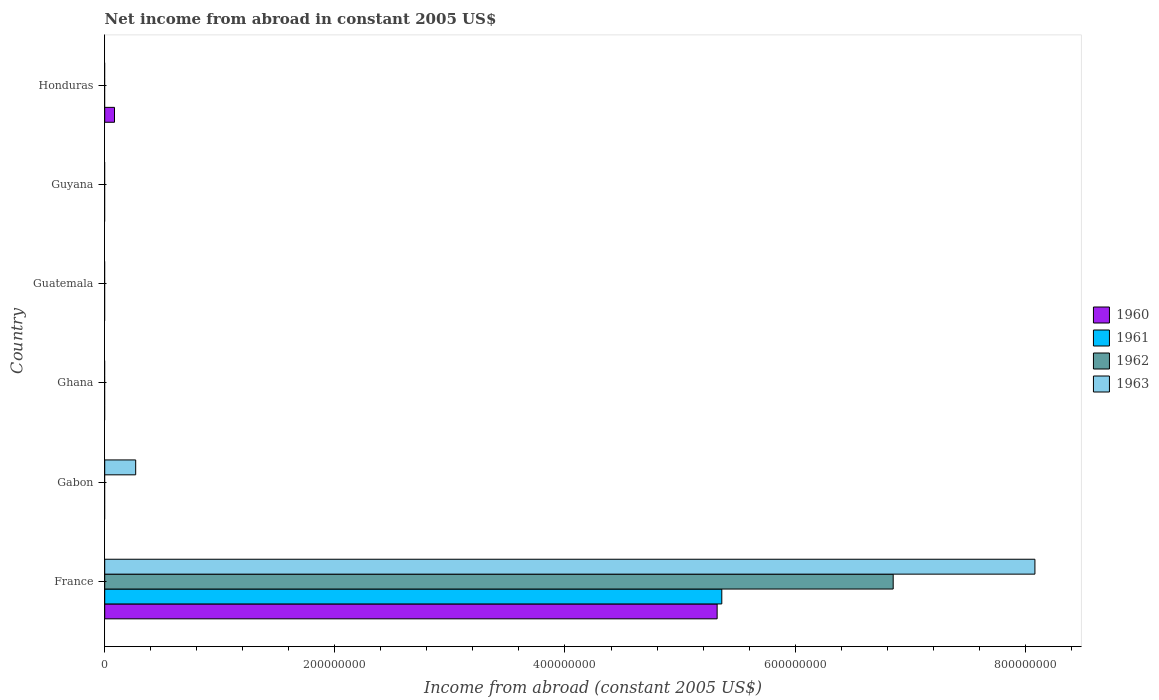How many different coloured bars are there?
Offer a very short reply. 4. Are the number of bars per tick equal to the number of legend labels?
Give a very brief answer. No. How many bars are there on the 2nd tick from the bottom?
Ensure brevity in your answer.  1. What is the label of the 3rd group of bars from the top?
Offer a terse response. Guatemala. In how many cases, is the number of bars for a given country not equal to the number of legend labels?
Your answer should be very brief. 5. Across all countries, what is the maximum net income from abroad in 1962?
Your answer should be very brief. 6.85e+08. In which country was the net income from abroad in 1962 maximum?
Your answer should be compact. France. What is the total net income from abroad in 1960 in the graph?
Your response must be concise. 5.41e+08. What is the difference between the net income from abroad in 1960 in France and that in Honduras?
Provide a succinct answer. 5.24e+08. What is the difference between the net income from abroad in 1961 in Guatemala and the net income from abroad in 1963 in Gabon?
Provide a succinct answer. -2.69e+07. What is the average net income from abroad in 1963 per country?
Provide a short and direct response. 1.39e+08. What is the difference between the highest and the lowest net income from abroad in 1962?
Provide a succinct answer. 6.85e+08. In how many countries, is the net income from abroad in 1962 greater than the average net income from abroad in 1962 taken over all countries?
Ensure brevity in your answer.  1. Is it the case that in every country, the sum of the net income from abroad in 1960 and net income from abroad in 1962 is greater than the net income from abroad in 1963?
Provide a succinct answer. No. How many bars are there?
Keep it short and to the point. 6. What is the difference between two consecutive major ticks on the X-axis?
Provide a succinct answer. 2.00e+08. Does the graph contain grids?
Ensure brevity in your answer.  No. Where does the legend appear in the graph?
Your answer should be compact. Center right. How many legend labels are there?
Keep it short and to the point. 4. What is the title of the graph?
Make the answer very short. Net income from abroad in constant 2005 US$. What is the label or title of the X-axis?
Give a very brief answer. Income from abroad (constant 2005 US$). What is the Income from abroad (constant 2005 US$) of 1960 in France?
Keep it short and to the point. 5.32e+08. What is the Income from abroad (constant 2005 US$) in 1961 in France?
Give a very brief answer. 5.36e+08. What is the Income from abroad (constant 2005 US$) of 1962 in France?
Provide a succinct answer. 6.85e+08. What is the Income from abroad (constant 2005 US$) in 1963 in France?
Offer a terse response. 8.08e+08. What is the Income from abroad (constant 2005 US$) in 1960 in Gabon?
Offer a terse response. 0. What is the Income from abroad (constant 2005 US$) in 1963 in Gabon?
Offer a terse response. 2.69e+07. What is the Income from abroad (constant 2005 US$) of 1960 in Ghana?
Provide a short and direct response. 0. What is the Income from abroad (constant 2005 US$) of 1961 in Ghana?
Provide a succinct answer. 0. What is the Income from abroad (constant 2005 US$) in 1963 in Ghana?
Offer a very short reply. 0. What is the Income from abroad (constant 2005 US$) in 1963 in Guatemala?
Offer a terse response. 0. What is the Income from abroad (constant 2005 US$) in 1960 in Guyana?
Provide a succinct answer. 0. What is the Income from abroad (constant 2005 US$) in 1963 in Guyana?
Your response must be concise. 0. What is the Income from abroad (constant 2005 US$) of 1960 in Honduras?
Offer a very short reply. 8.50e+06. What is the Income from abroad (constant 2005 US$) in 1961 in Honduras?
Provide a short and direct response. 0. Across all countries, what is the maximum Income from abroad (constant 2005 US$) in 1960?
Your answer should be very brief. 5.32e+08. Across all countries, what is the maximum Income from abroad (constant 2005 US$) of 1961?
Provide a succinct answer. 5.36e+08. Across all countries, what is the maximum Income from abroad (constant 2005 US$) of 1962?
Offer a very short reply. 6.85e+08. Across all countries, what is the maximum Income from abroad (constant 2005 US$) of 1963?
Ensure brevity in your answer.  8.08e+08. Across all countries, what is the minimum Income from abroad (constant 2005 US$) of 1963?
Provide a succinct answer. 0. What is the total Income from abroad (constant 2005 US$) in 1960 in the graph?
Give a very brief answer. 5.41e+08. What is the total Income from abroad (constant 2005 US$) of 1961 in the graph?
Your answer should be compact. 5.36e+08. What is the total Income from abroad (constant 2005 US$) of 1962 in the graph?
Make the answer very short. 6.85e+08. What is the total Income from abroad (constant 2005 US$) of 1963 in the graph?
Your response must be concise. 8.35e+08. What is the difference between the Income from abroad (constant 2005 US$) in 1963 in France and that in Gabon?
Make the answer very short. 7.81e+08. What is the difference between the Income from abroad (constant 2005 US$) in 1960 in France and that in Honduras?
Make the answer very short. 5.24e+08. What is the difference between the Income from abroad (constant 2005 US$) in 1960 in France and the Income from abroad (constant 2005 US$) in 1963 in Gabon?
Your answer should be very brief. 5.05e+08. What is the difference between the Income from abroad (constant 2005 US$) in 1961 in France and the Income from abroad (constant 2005 US$) in 1963 in Gabon?
Offer a terse response. 5.09e+08. What is the difference between the Income from abroad (constant 2005 US$) of 1962 in France and the Income from abroad (constant 2005 US$) of 1963 in Gabon?
Offer a terse response. 6.58e+08. What is the average Income from abroad (constant 2005 US$) in 1960 per country?
Your answer should be compact. 9.01e+07. What is the average Income from abroad (constant 2005 US$) in 1961 per country?
Your response must be concise. 8.94e+07. What is the average Income from abroad (constant 2005 US$) of 1962 per country?
Provide a succinct answer. 1.14e+08. What is the average Income from abroad (constant 2005 US$) of 1963 per country?
Keep it short and to the point. 1.39e+08. What is the difference between the Income from abroad (constant 2005 US$) of 1960 and Income from abroad (constant 2005 US$) of 1961 in France?
Make the answer very short. -4.05e+06. What is the difference between the Income from abroad (constant 2005 US$) in 1960 and Income from abroad (constant 2005 US$) in 1962 in France?
Provide a short and direct response. -1.53e+08. What is the difference between the Income from abroad (constant 2005 US$) in 1960 and Income from abroad (constant 2005 US$) in 1963 in France?
Give a very brief answer. -2.76e+08. What is the difference between the Income from abroad (constant 2005 US$) in 1961 and Income from abroad (constant 2005 US$) in 1962 in France?
Your answer should be very brief. -1.49e+08. What is the difference between the Income from abroad (constant 2005 US$) of 1961 and Income from abroad (constant 2005 US$) of 1963 in France?
Provide a succinct answer. -2.72e+08. What is the difference between the Income from abroad (constant 2005 US$) in 1962 and Income from abroad (constant 2005 US$) in 1963 in France?
Ensure brevity in your answer.  -1.23e+08. What is the ratio of the Income from abroad (constant 2005 US$) in 1963 in France to that in Gabon?
Make the answer very short. 30.04. What is the ratio of the Income from abroad (constant 2005 US$) of 1960 in France to that in Honduras?
Ensure brevity in your answer.  62.61. What is the difference between the highest and the lowest Income from abroad (constant 2005 US$) of 1960?
Give a very brief answer. 5.32e+08. What is the difference between the highest and the lowest Income from abroad (constant 2005 US$) of 1961?
Ensure brevity in your answer.  5.36e+08. What is the difference between the highest and the lowest Income from abroad (constant 2005 US$) in 1962?
Ensure brevity in your answer.  6.85e+08. What is the difference between the highest and the lowest Income from abroad (constant 2005 US$) of 1963?
Keep it short and to the point. 8.08e+08. 